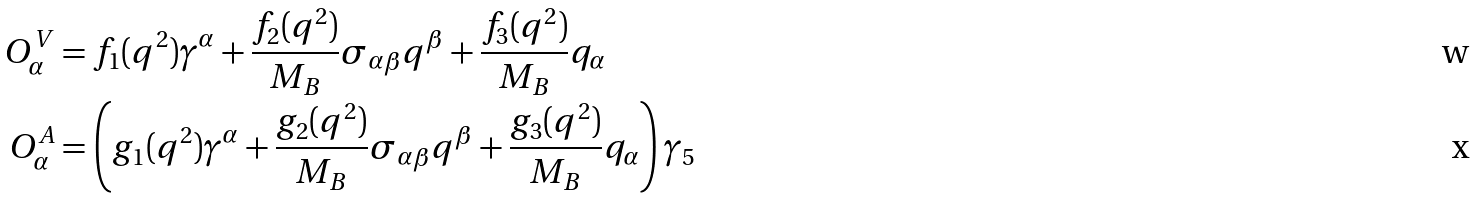Convert formula to latex. <formula><loc_0><loc_0><loc_500><loc_500>O ^ { V } _ { \alpha } & = f _ { 1 } ( q ^ { 2 } ) \gamma ^ { \alpha } + \frac { f _ { 2 } ( q ^ { 2 } ) } { M _ { B } } \sigma _ { \alpha \beta } q ^ { \beta } + \frac { f _ { 3 } ( q ^ { 2 } ) } { M _ { B } } q _ { \alpha } \\ O ^ { A } _ { \alpha } & = \left ( g _ { 1 } ( q ^ { 2 } ) \gamma ^ { \alpha } + \frac { g _ { 2 } ( q ^ { 2 } ) } { M _ { B } } \sigma _ { \alpha \beta } q ^ { \beta } + \frac { g _ { 3 } ( q ^ { 2 } ) } { M _ { B } } q _ { \alpha } \right ) \gamma _ { 5 }</formula> 